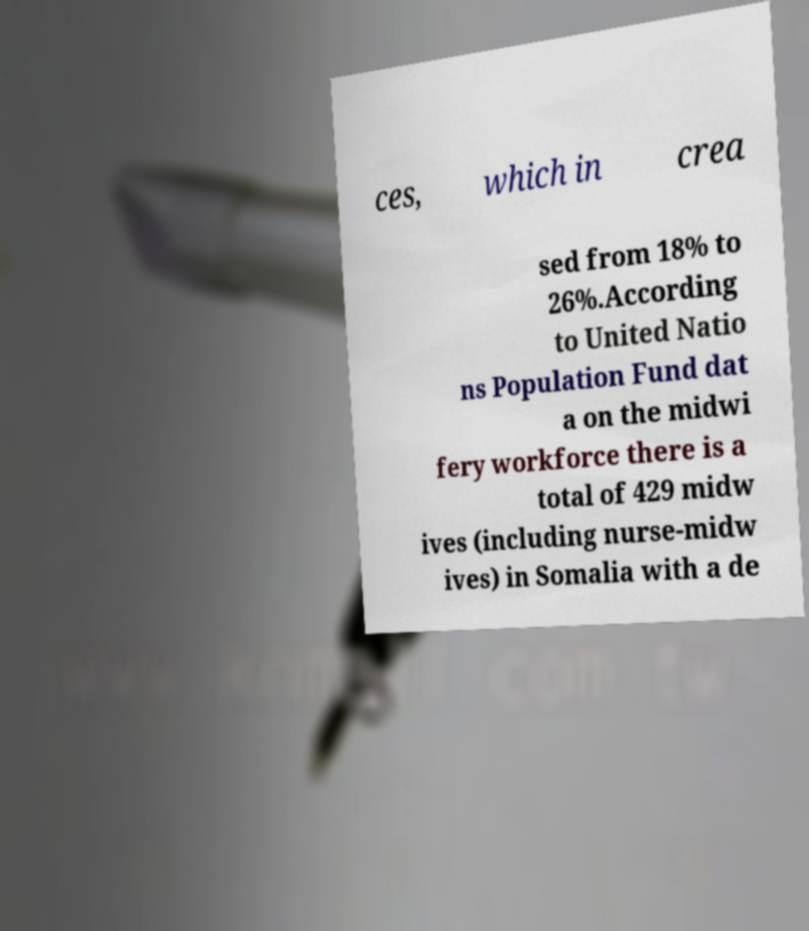There's text embedded in this image that I need extracted. Can you transcribe it verbatim? ces, which in crea sed from 18% to 26%.According to United Natio ns Population Fund dat a on the midwi fery workforce there is a total of 429 midw ives (including nurse-midw ives) in Somalia with a de 